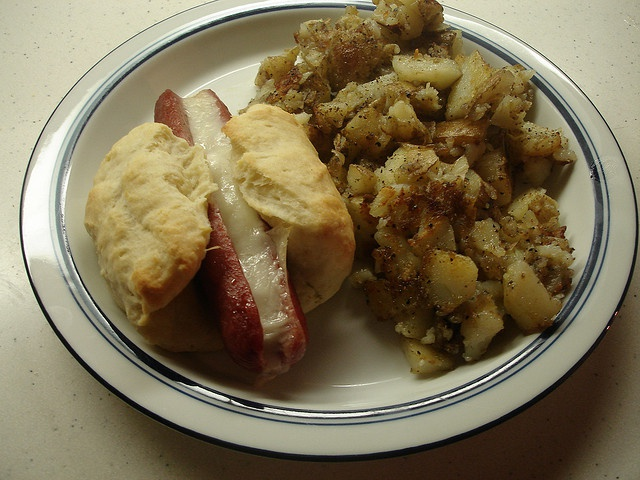Describe the objects in this image and their specific colors. I can see dining table in beige, black, darkgray, and gray tones and hot dog in tan, black, and maroon tones in this image. 